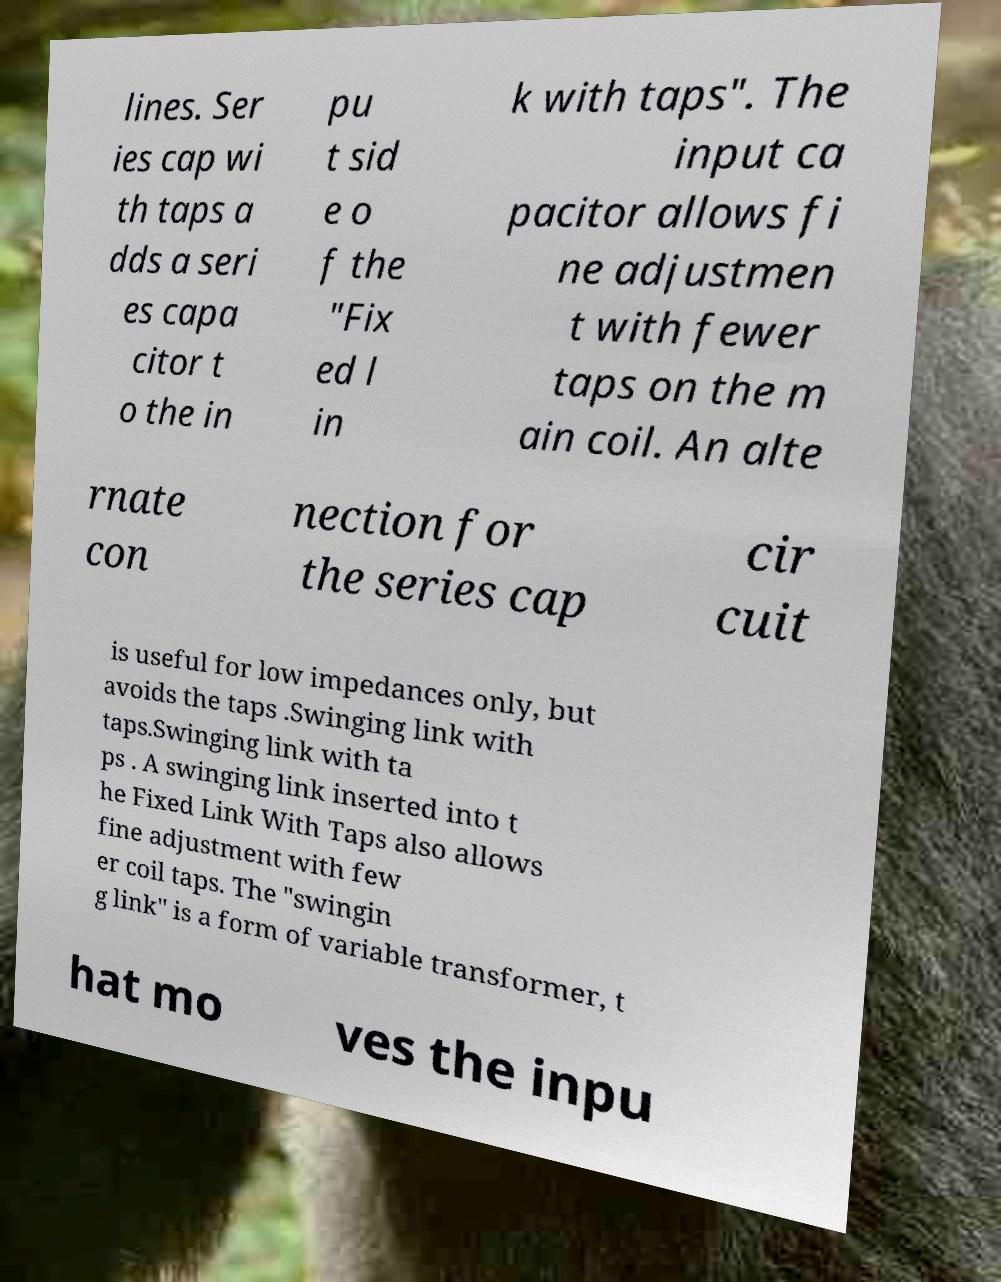There's text embedded in this image that I need extracted. Can you transcribe it verbatim? lines. Ser ies cap wi th taps a dds a seri es capa citor t o the in pu t sid e o f the "Fix ed l in k with taps". The input ca pacitor allows fi ne adjustmen t with fewer taps on the m ain coil. An alte rnate con nection for the series cap cir cuit is useful for low impedances only, but avoids the taps .Swinging link with taps.Swinging link with ta ps . A swinging link inserted into t he Fixed Link With Taps also allows fine adjustment with few er coil taps. The "swingin g link" is a form of variable transformer, t hat mo ves the inpu 